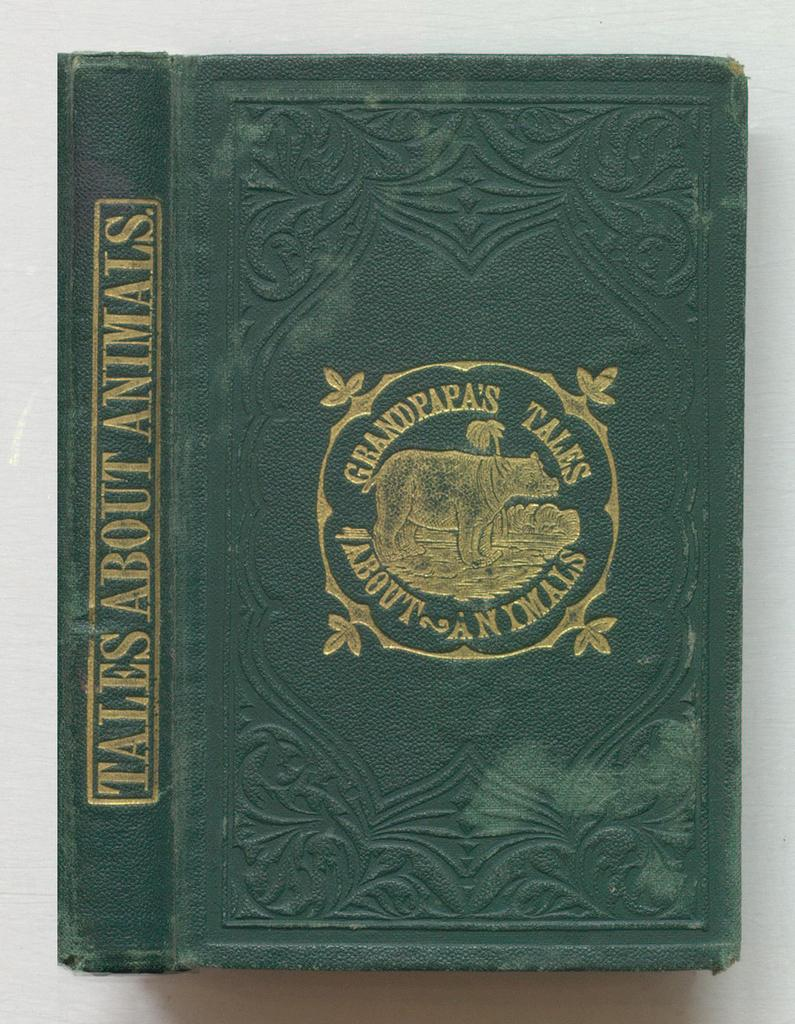Provide a one-sentence caption for the provided image. An old green book about animals has gold embossing. 